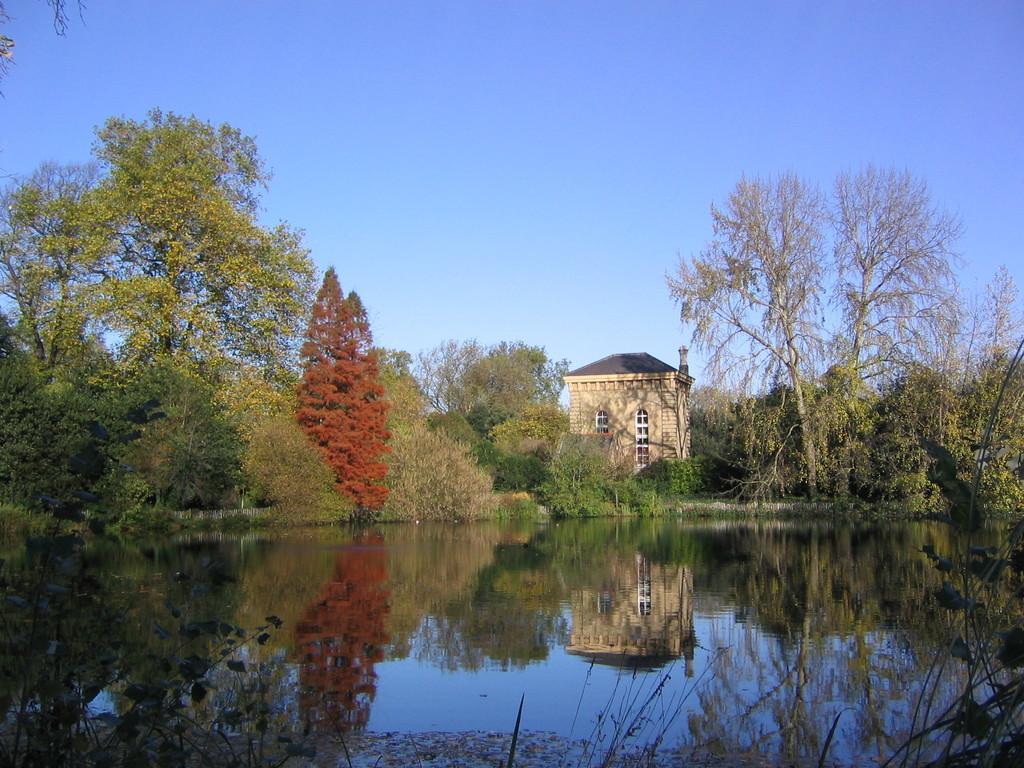Describe this image in one or two sentences. In this image there is a house, before it there are few plants. Background there are few trees. Top of image there is sky. Bottom of image there is water having reflection of a house, plants and trees. Right bottom there is grass. Left bottom there are few plants. 